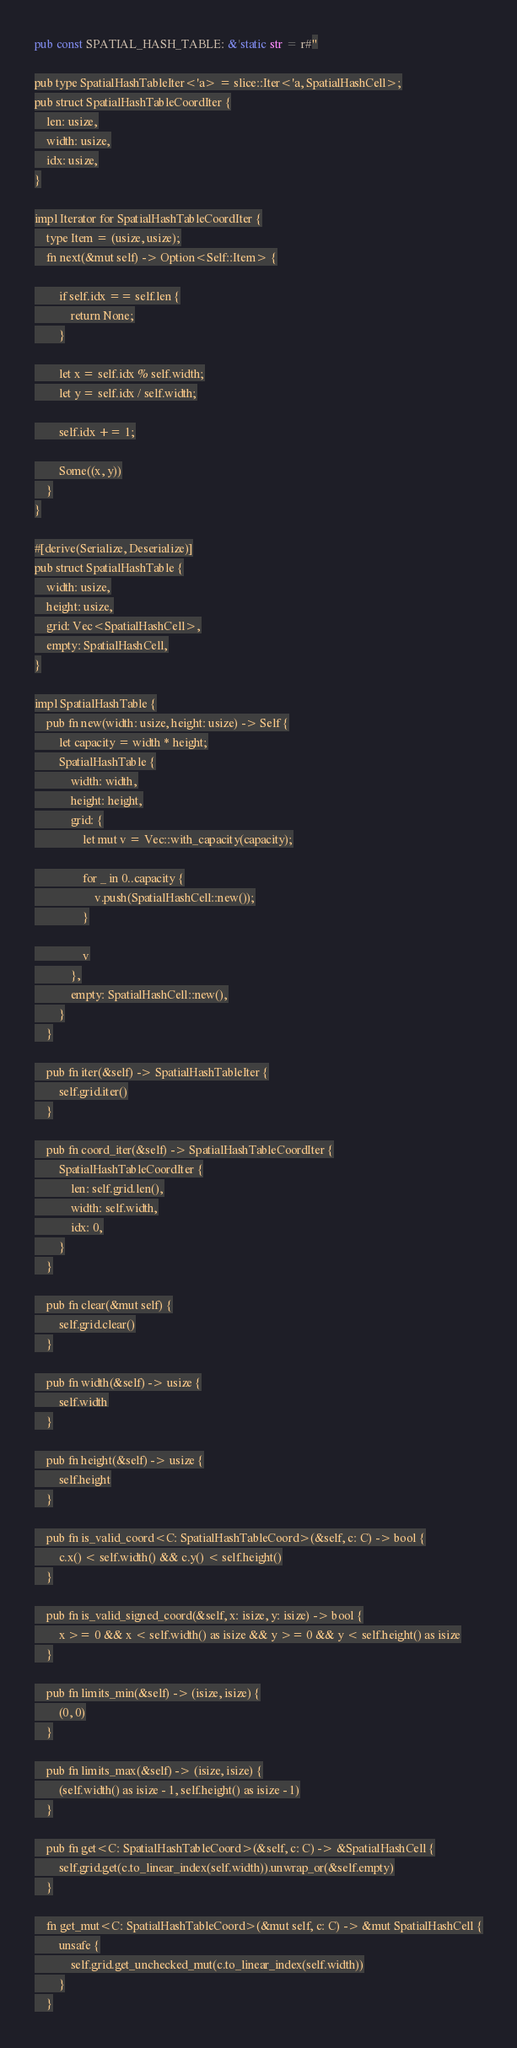Convert code to text. <code><loc_0><loc_0><loc_500><loc_500><_Rust_>pub const SPATIAL_HASH_TABLE: &'static str = r#"

pub type SpatialHashTableIter<'a> = slice::Iter<'a, SpatialHashCell>;
pub struct SpatialHashTableCoordIter {
    len: usize,
    width: usize,
    idx: usize,
}

impl Iterator for SpatialHashTableCoordIter {
    type Item = (usize, usize);
    fn next(&mut self) -> Option<Self::Item> {

        if self.idx == self.len {
            return None;
        }

        let x = self.idx % self.width;
        let y = self.idx / self.width;

        self.idx += 1;

        Some((x, y))
    }
}

#[derive(Serialize, Deserialize)]
pub struct SpatialHashTable {
    width: usize,
    height: usize,
    grid: Vec<SpatialHashCell>,
    empty: SpatialHashCell,
}

impl SpatialHashTable {
    pub fn new(width: usize, height: usize) -> Self {
        let capacity = width * height;
        SpatialHashTable {
            width: width,
            height: height,
            grid: {
                let mut v = Vec::with_capacity(capacity);

                for _ in 0..capacity {
                    v.push(SpatialHashCell::new());
                }

                v
            },
            empty: SpatialHashCell::new(),
        }
    }

    pub fn iter(&self) -> SpatialHashTableIter {
        self.grid.iter()
    }

    pub fn coord_iter(&self) -> SpatialHashTableCoordIter {
        SpatialHashTableCoordIter {
            len: self.grid.len(),
            width: self.width,
            idx: 0,
        }
    }

    pub fn clear(&mut self) {
        self.grid.clear()
    }

    pub fn width(&self) -> usize {
        self.width
    }

    pub fn height(&self) -> usize {
        self.height
    }

    pub fn is_valid_coord<C: SpatialHashTableCoord>(&self, c: C) -> bool {
        c.x() < self.width() && c.y() < self.height()
    }

    pub fn is_valid_signed_coord(&self, x: isize, y: isize) -> bool {
        x >= 0 && x < self.width() as isize && y >= 0 && y < self.height() as isize
    }

    pub fn limits_min(&self) -> (isize, isize) {
        (0, 0)
    }

    pub fn limits_max(&self) -> (isize, isize) {
        (self.width() as isize - 1, self.height() as isize - 1)
    }

    pub fn get<C: SpatialHashTableCoord>(&self, c: C) -> &SpatialHashCell {
        self.grid.get(c.to_linear_index(self.width)).unwrap_or(&self.empty)
    }

    fn get_mut<C: SpatialHashTableCoord>(&mut self, c: C) -> &mut SpatialHashCell {
        unsafe {
            self.grid.get_unchecked_mut(c.to_linear_index(self.width))
        }
    }
</code> 